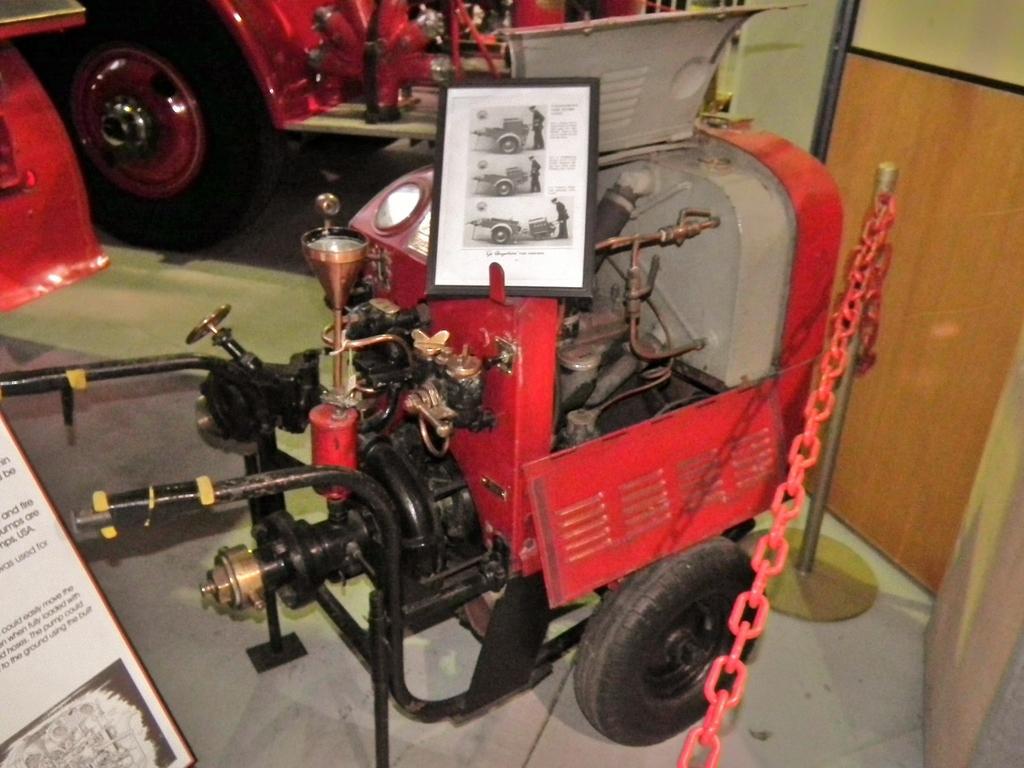In one or two sentences, can you explain what this image depicts? In this image I can see an engine which is black and red in color which has wheels. I can see a photo frame on the engine. I can see a pole, a red colored chain to the pole and in the background I can see a red colored vehicle on the floor. 